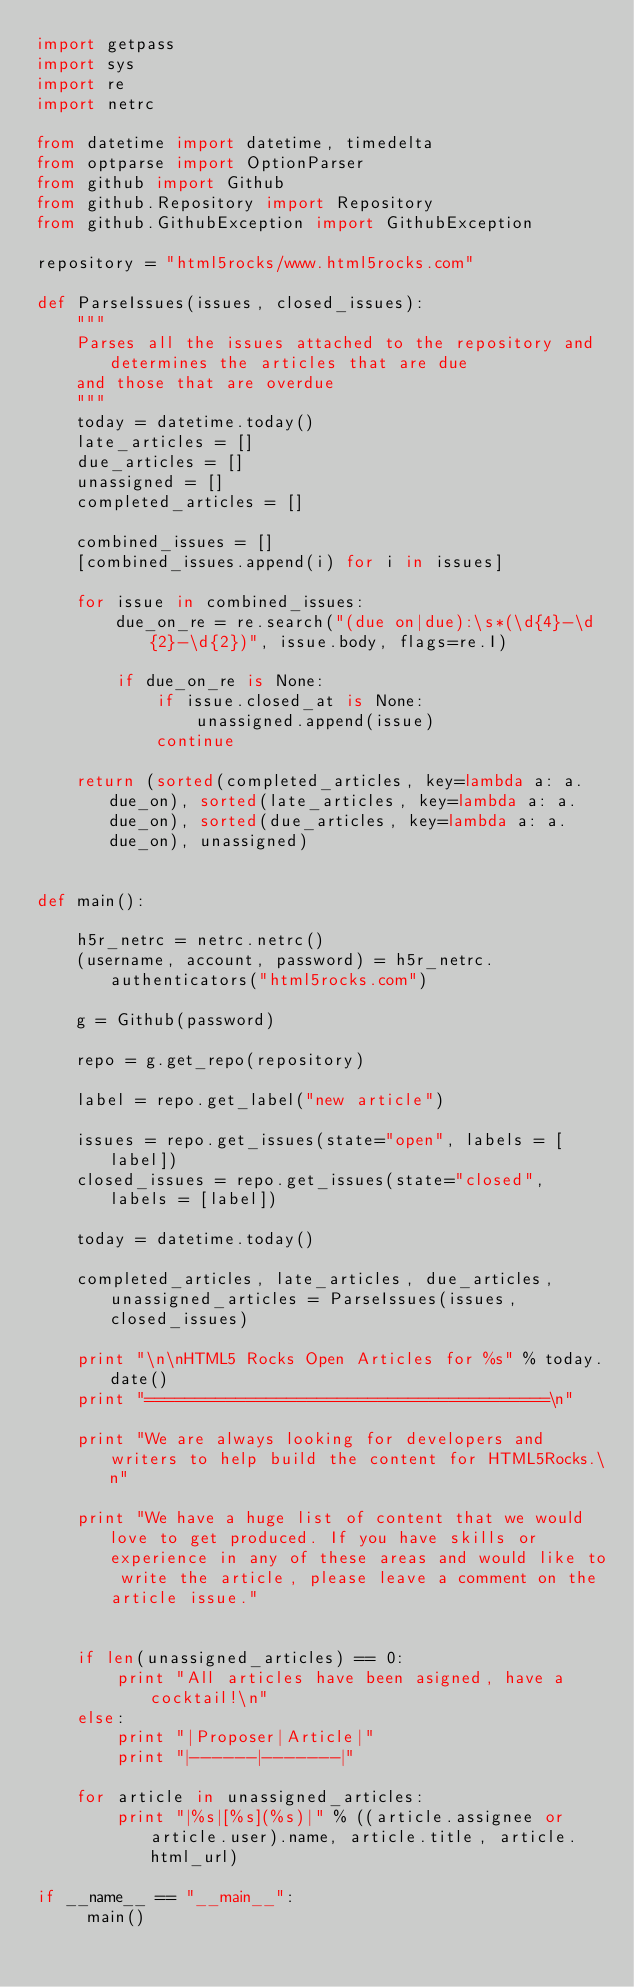<code> <loc_0><loc_0><loc_500><loc_500><_Python_>import getpass
import sys
import re
import netrc

from datetime import datetime, timedelta
from optparse import OptionParser
from github import Github
from github.Repository import Repository
from github.GithubException import GithubException

repository = "html5rocks/www.html5rocks.com"

def ParseIssues(issues, closed_issues):
    """
    Parses all the issues attached to the repository and determines the articles that are due
    and those that are overdue
    """
    today = datetime.today()
    late_articles = []
    due_articles = []
    unassigned = []
    completed_articles = []
 
    combined_issues = []
    [combined_issues.append(i) for i in issues]

    for issue in combined_issues:
        due_on_re = re.search("(due on|due):\s*(\d{4}-\d{2}-\d{2})", issue.body, flags=re.I)
        
        if due_on_re is None:
            if issue.closed_at is None:
                unassigned.append(issue)
            continue

    return (sorted(completed_articles, key=lambda a: a.due_on), sorted(late_articles, key=lambda a: a.due_on), sorted(due_articles, key=lambda a: a.due_on), unassigned)


def main():

    h5r_netrc = netrc.netrc()
    (username, account, password) = h5r_netrc.authenticators("html5rocks.com")
    
    g = Github(password)

    repo = g.get_repo(repository)
   
    label = repo.get_label("new article")

    issues = repo.get_issues(state="open", labels = [label])
    closed_issues = repo.get_issues(state="closed", labels = [label])

    today = datetime.today()

    completed_articles, late_articles, due_articles, unassigned_articles = ParseIssues(issues, closed_issues)

    print "\n\nHTML5 Rocks Open Articles for %s" % today.date()
    print "========================================\n"

    print "We are always looking for developers and writers to help build the content for HTML5Rocks.\n"

    print "We have a huge list of content that we would love to get produced. If you have skills or experience in any of these areas and would like to write the article, please leave a comment on the article issue."


    if len(unassigned_articles) == 0:
        print "All articles have been asigned, have a cocktail!\n"
    else:
        print "|Proposer|Article|"
        print "|------|-------|"
    
    for article in unassigned_articles:
        print "|%s|[%s](%s)|" % ((article.assignee or article.user).name, article.title, article.html_url)
   
if __name__ == "__main__":
     main()
</code> 